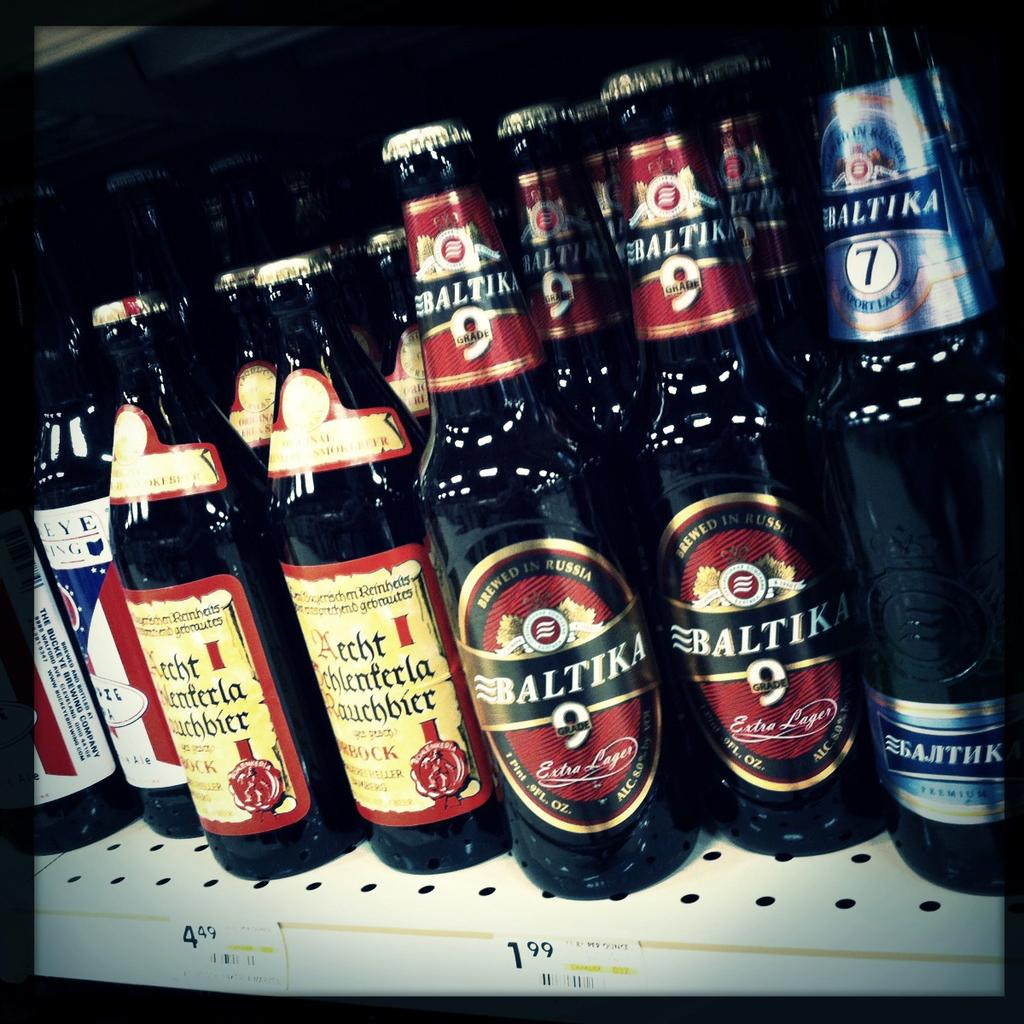<image>
Offer a succinct explanation of the picture presented. Two varieties of Baltika beer are displayed on a shelf next to other import beers. 